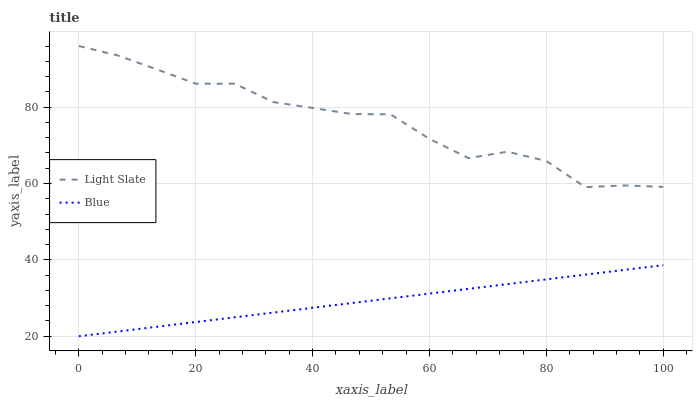Does Blue have the maximum area under the curve?
Answer yes or no. No. Is Blue the roughest?
Answer yes or no. No. Does Blue have the highest value?
Answer yes or no. No. Is Blue less than Light Slate?
Answer yes or no. Yes. Is Light Slate greater than Blue?
Answer yes or no. Yes. Does Blue intersect Light Slate?
Answer yes or no. No. 